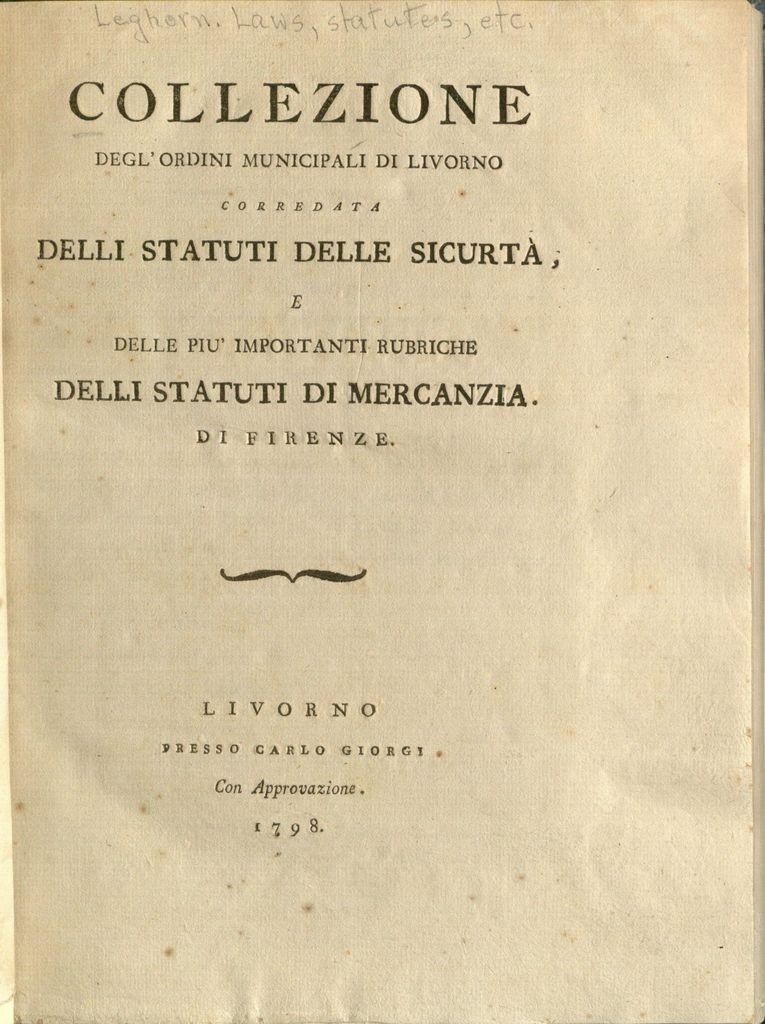<image>
Provide a brief description of the given image. An old book from 1798 is titled Collezione 